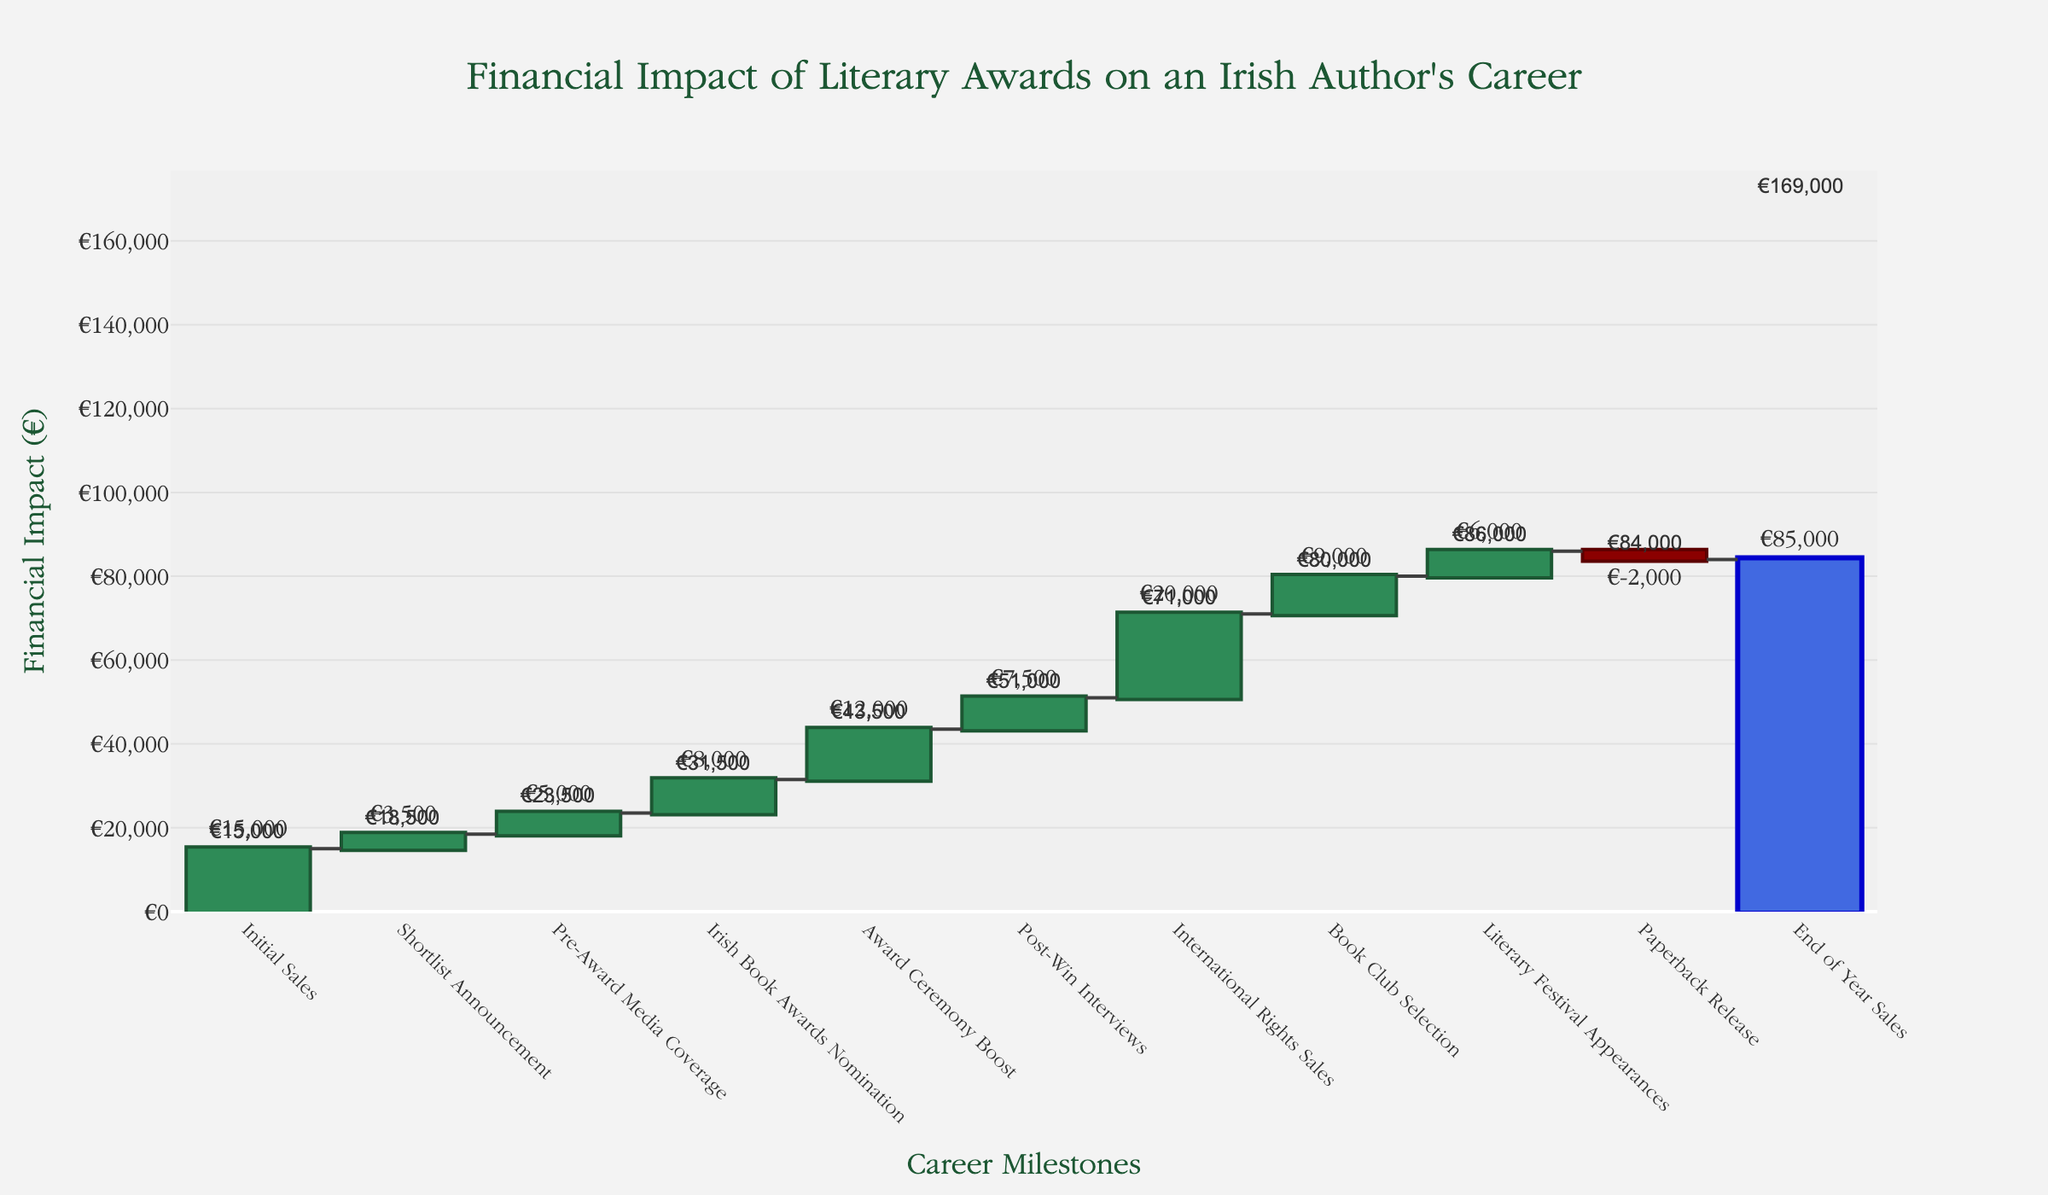What is the title of the waterfall chart? The title of the chart is usually found at the top, and it provides a description of what the chart is about. In this case, it specifies the impact of literary awards on an Irish author's career.
Answer: Financial Impact of Literary Awards on an Irish Author's Career Which element shows the smallest financial impact on the author's career? The smallest financial impact can be identified by looking for the category with the smallest bar. Specifically, we see that the "Paperback Release" has a negative impact of €2000.
Answer: Paperback Release What is the cumulative earnings from the "Irish Book Awards Nomination" phase? To determine this, find the cumulative earnings mentioned in the annotation above the "Irish Book Awards Nomination" bar. This step shows a cumulative value of €31500.
Answer: €31,500 What categories contribute to the total post-win impact? The categories contributing to the post-win impact are those events occurring after the "Award Ceremony Boost" and leading up to the "End of Year Sales" category. These include Post-Win Interviews, International Rights Sales, Book Club Selection, Literary Festival Appearances, and Paperback Release.
Answer: Post-Win Interviews, International Rights Sales, Book Club Selection, Literary Festival Appearances, Paperback Release How much is the total financial impact at the end of the year? The total financial impact at the end of the year is represented by the final bar with the annotation above it. This is the “End of Year Sales” bar which shows a cumulative total of €85000.
Answer: €85,000 By how much does the "Award Ceremony Boost" increase the financial impact compared to "Pre-Award Media Coverage"? First, locate the value of "Award Ceremony Boost" (€12000) and the value of "Pre-Award Media Coverage" (€5000). Subtracting the latter from the former gives the difference: 12000 - 5000 = 7000.
Answer: €7,000 Which category shows the highest increase in financial impact? The highest increase can be recognized by the tallest positive bar. The tallest green bar corresponds to "International Rights Sales," which has a value of €20000.
Answer: International Rights Sales What is the combined financial impact of "Shortlist Announcement" and "Pre-Award Media Coverage"? Adding the financial impacts of "Shortlist Announcement" (€3500) and "Pre-Award Media Coverage" (€5000) involves summing the two values: 3500 + 5000 = 8500.
Answer: €8,500 What is the net effect of the "Paperback Release" on the total cumulative impact? The net effect is shown as a negative impact in the waterfall chart. The "Paperback Release" has a financial effect of -€2000, which means it subtracts from the total impact.
Answer: -€2,000 